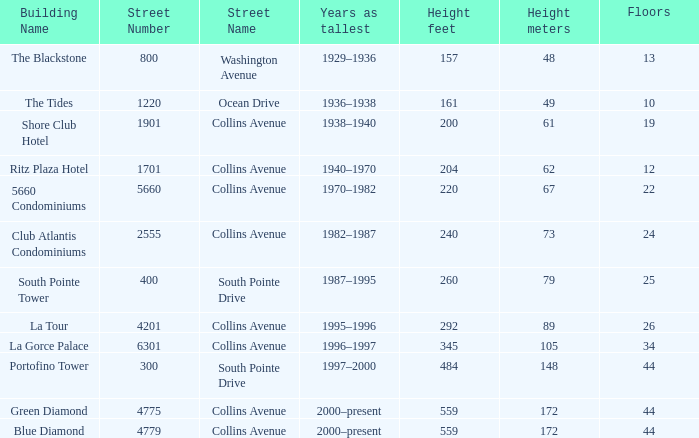What is the height of the Tides with less than 34 floors? 161 / 49. 